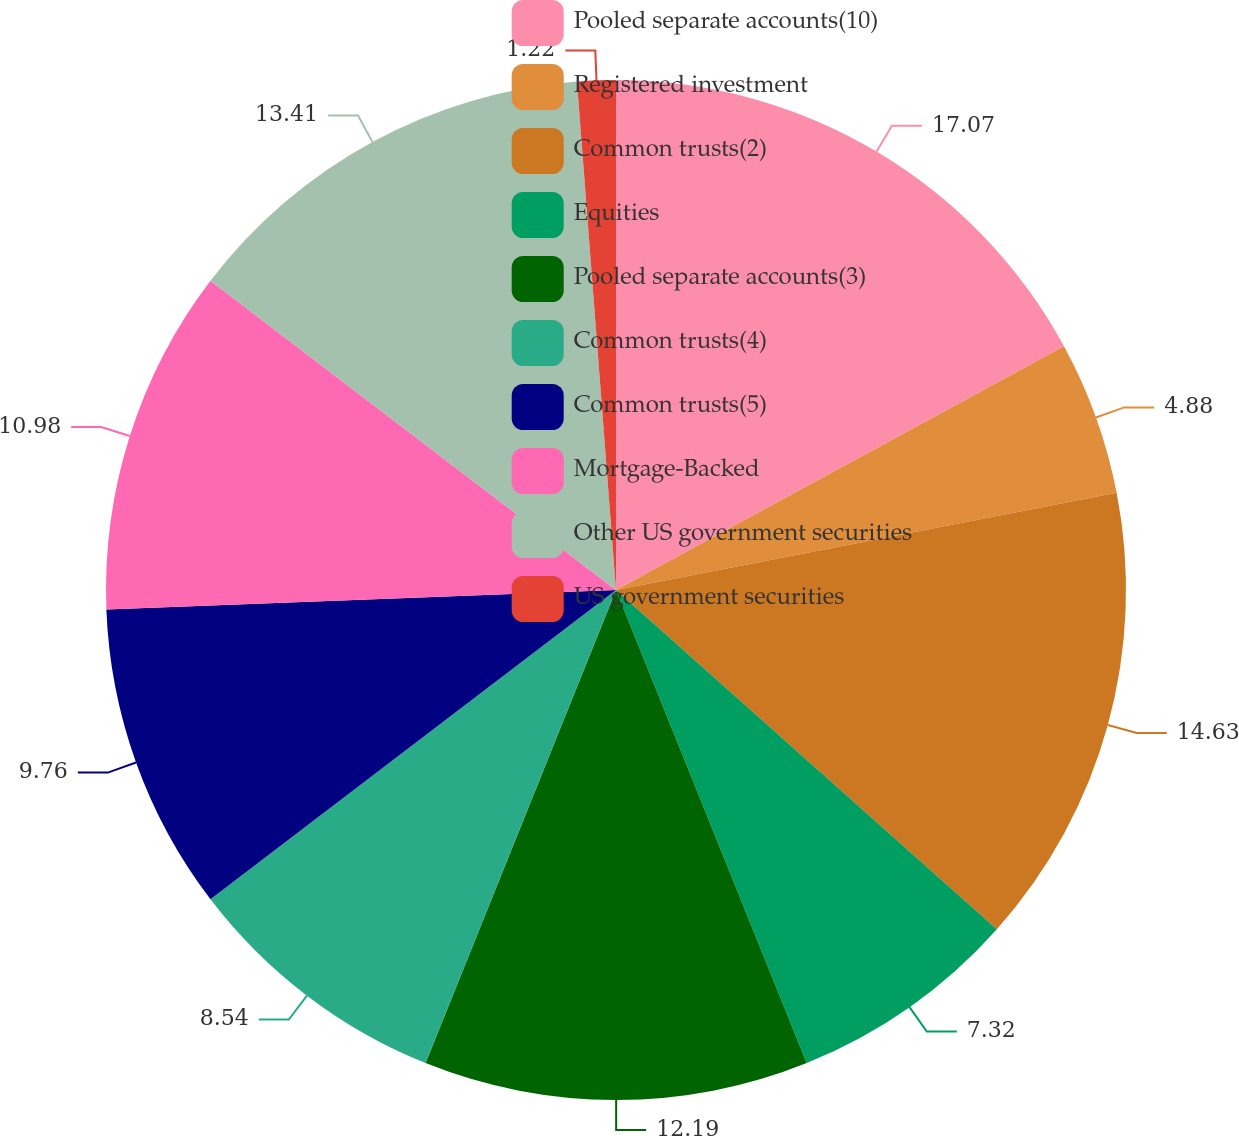<chart> <loc_0><loc_0><loc_500><loc_500><pie_chart><fcel>Pooled separate accounts(10)<fcel>Registered investment<fcel>Common trusts(2)<fcel>Equities<fcel>Pooled separate accounts(3)<fcel>Common trusts(4)<fcel>Common trusts(5)<fcel>Mortgage-Backed<fcel>Other US government securities<fcel>US government securities<nl><fcel>17.07%<fcel>4.88%<fcel>14.63%<fcel>7.32%<fcel>12.19%<fcel>8.54%<fcel>9.76%<fcel>10.98%<fcel>13.41%<fcel>1.22%<nl></chart> 